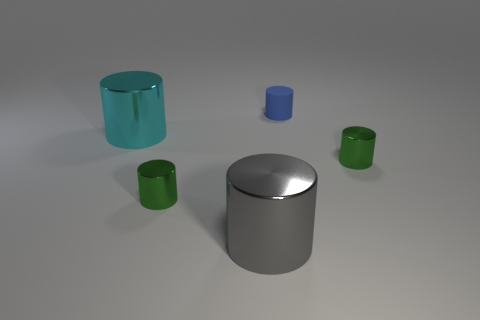Subtract all big cyan shiny cylinders. How many cylinders are left? 4 Subtract all gray cylinders. How many cylinders are left? 4 Subtract 1 cylinders. How many cylinders are left? 4 Subtract all brown cylinders. Subtract all cyan balls. How many cylinders are left? 5 Add 2 large yellow metallic balls. How many objects exist? 7 Add 3 blue rubber objects. How many blue rubber objects are left? 4 Add 5 big yellow spheres. How many big yellow spheres exist? 5 Subtract 1 blue cylinders. How many objects are left? 4 Subtract all big blue metallic cubes. Subtract all small cylinders. How many objects are left? 2 